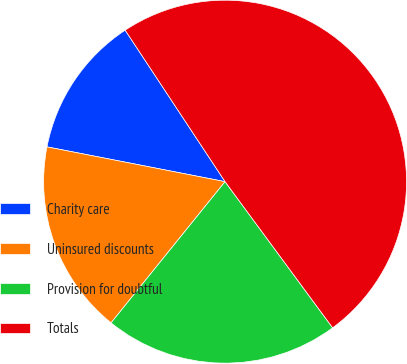Convert chart. <chart><loc_0><loc_0><loc_500><loc_500><pie_chart><fcel>Charity care<fcel>Uninsured discounts<fcel>Provision for doubtful<fcel>Totals<nl><fcel>12.65%<fcel>17.26%<fcel>20.91%<fcel>49.18%<nl></chart> 